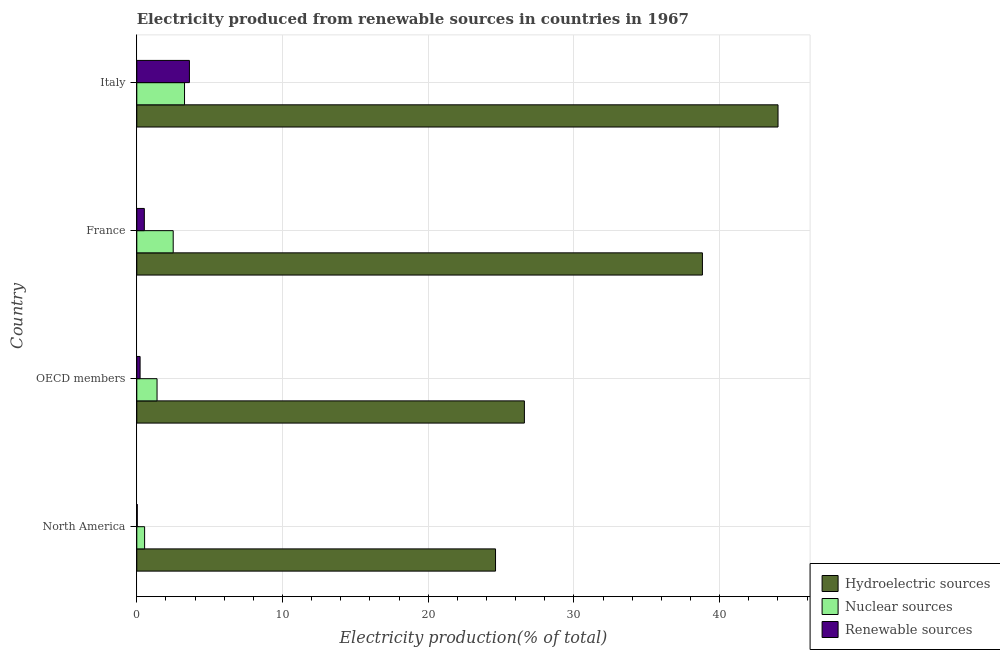How many different coloured bars are there?
Provide a succinct answer. 3. How many groups of bars are there?
Your answer should be compact. 4. In how many cases, is the number of bars for a given country not equal to the number of legend labels?
Provide a short and direct response. 0. What is the percentage of electricity produced by hydroelectric sources in OECD members?
Your answer should be very brief. 26.6. Across all countries, what is the maximum percentage of electricity produced by renewable sources?
Offer a terse response. 3.61. Across all countries, what is the minimum percentage of electricity produced by hydroelectric sources?
Give a very brief answer. 24.62. In which country was the percentage of electricity produced by renewable sources maximum?
Your answer should be compact. Italy. In which country was the percentage of electricity produced by nuclear sources minimum?
Ensure brevity in your answer.  North America. What is the total percentage of electricity produced by hydroelectric sources in the graph?
Provide a succinct answer. 134.03. What is the difference between the percentage of electricity produced by nuclear sources in Italy and that in North America?
Provide a short and direct response. 2.74. What is the difference between the percentage of electricity produced by renewable sources in North America and the percentage of electricity produced by nuclear sources in France?
Give a very brief answer. -2.47. What is the average percentage of electricity produced by nuclear sources per country?
Your answer should be very brief. 1.93. What is the difference between the percentage of electricity produced by renewable sources and percentage of electricity produced by nuclear sources in Italy?
Your answer should be compact. 0.34. What is the ratio of the percentage of electricity produced by renewable sources in Italy to that in North America?
Your answer should be very brief. 110.84. Is the percentage of electricity produced by renewable sources in Italy less than that in OECD members?
Make the answer very short. No. Is the difference between the percentage of electricity produced by hydroelectric sources in North America and OECD members greater than the difference between the percentage of electricity produced by nuclear sources in North America and OECD members?
Keep it short and to the point. No. What is the difference between the highest and the second highest percentage of electricity produced by hydroelectric sources?
Keep it short and to the point. 5.19. What is the difference between the highest and the lowest percentage of electricity produced by hydroelectric sources?
Provide a short and direct response. 19.39. What does the 2nd bar from the top in OECD members represents?
Give a very brief answer. Nuclear sources. What does the 3rd bar from the bottom in France represents?
Make the answer very short. Renewable sources. How many bars are there?
Give a very brief answer. 12. Are all the bars in the graph horizontal?
Keep it short and to the point. Yes. Are the values on the major ticks of X-axis written in scientific E-notation?
Provide a short and direct response. No. Does the graph contain any zero values?
Provide a succinct answer. No. What is the title of the graph?
Your answer should be compact. Electricity produced from renewable sources in countries in 1967. What is the label or title of the Y-axis?
Ensure brevity in your answer.  Country. What is the Electricity production(% of total) in Hydroelectric sources in North America?
Your answer should be very brief. 24.62. What is the Electricity production(% of total) of Nuclear sources in North America?
Offer a very short reply. 0.54. What is the Electricity production(% of total) of Renewable sources in North America?
Give a very brief answer. 0.03. What is the Electricity production(% of total) in Hydroelectric sources in OECD members?
Make the answer very short. 26.6. What is the Electricity production(% of total) of Nuclear sources in OECD members?
Ensure brevity in your answer.  1.39. What is the Electricity production(% of total) in Renewable sources in OECD members?
Offer a very short reply. 0.23. What is the Electricity production(% of total) of Hydroelectric sources in France?
Your response must be concise. 38.81. What is the Electricity production(% of total) in Nuclear sources in France?
Keep it short and to the point. 2.5. What is the Electricity production(% of total) of Renewable sources in France?
Your response must be concise. 0.52. What is the Electricity production(% of total) in Hydroelectric sources in Italy?
Your answer should be very brief. 44. What is the Electricity production(% of total) of Nuclear sources in Italy?
Give a very brief answer. 3.28. What is the Electricity production(% of total) of Renewable sources in Italy?
Your response must be concise. 3.61. Across all countries, what is the maximum Electricity production(% of total) in Hydroelectric sources?
Your response must be concise. 44. Across all countries, what is the maximum Electricity production(% of total) in Nuclear sources?
Provide a short and direct response. 3.28. Across all countries, what is the maximum Electricity production(% of total) of Renewable sources?
Ensure brevity in your answer.  3.61. Across all countries, what is the minimum Electricity production(% of total) of Hydroelectric sources?
Ensure brevity in your answer.  24.62. Across all countries, what is the minimum Electricity production(% of total) of Nuclear sources?
Keep it short and to the point. 0.54. Across all countries, what is the minimum Electricity production(% of total) of Renewable sources?
Your response must be concise. 0.03. What is the total Electricity production(% of total) of Hydroelectric sources in the graph?
Provide a short and direct response. 134.03. What is the total Electricity production(% of total) of Nuclear sources in the graph?
Offer a terse response. 7.7. What is the total Electricity production(% of total) of Renewable sources in the graph?
Provide a succinct answer. 4.39. What is the difference between the Electricity production(% of total) in Hydroelectric sources in North America and that in OECD members?
Your answer should be compact. -1.98. What is the difference between the Electricity production(% of total) in Nuclear sources in North America and that in OECD members?
Offer a very short reply. -0.85. What is the difference between the Electricity production(% of total) in Renewable sources in North America and that in OECD members?
Your answer should be compact. -0.19. What is the difference between the Electricity production(% of total) of Hydroelectric sources in North America and that in France?
Offer a terse response. -14.2. What is the difference between the Electricity production(% of total) of Nuclear sources in North America and that in France?
Provide a short and direct response. -1.96. What is the difference between the Electricity production(% of total) of Renewable sources in North America and that in France?
Ensure brevity in your answer.  -0.48. What is the difference between the Electricity production(% of total) of Hydroelectric sources in North America and that in Italy?
Your response must be concise. -19.39. What is the difference between the Electricity production(% of total) in Nuclear sources in North America and that in Italy?
Make the answer very short. -2.74. What is the difference between the Electricity production(% of total) of Renewable sources in North America and that in Italy?
Keep it short and to the point. -3.58. What is the difference between the Electricity production(% of total) in Hydroelectric sources in OECD members and that in France?
Your answer should be very brief. -12.22. What is the difference between the Electricity production(% of total) of Nuclear sources in OECD members and that in France?
Make the answer very short. -1.11. What is the difference between the Electricity production(% of total) in Renewable sources in OECD members and that in France?
Provide a short and direct response. -0.29. What is the difference between the Electricity production(% of total) in Hydroelectric sources in OECD members and that in Italy?
Ensure brevity in your answer.  -17.4. What is the difference between the Electricity production(% of total) in Nuclear sources in OECD members and that in Italy?
Keep it short and to the point. -1.89. What is the difference between the Electricity production(% of total) of Renewable sources in OECD members and that in Italy?
Make the answer very short. -3.38. What is the difference between the Electricity production(% of total) of Hydroelectric sources in France and that in Italy?
Keep it short and to the point. -5.19. What is the difference between the Electricity production(% of total) in Nuclear sources in France and that in Italy?
Your response must be concise. -0.78. What is the difference between the Electricity production(% of total) in Renewable sources in France and that in Italy?
Keep it short and to the point. -3.09. What is the difference between the Electricity production(% of total) of Hydroelectric sources in North America and the Electricity production(% of total) of Nuclear sources in OECD members?
Give a very brief answer. 23.23. What is the difference between the Electricity production(% of total) of Hydroelectric sources in North America and the Electricity production(% of total) of Renewable sources in OECD members?
Make the answer very short. 24.39. What is the difference between the Electricity production(% of total) in Nuclear sources in North America and the Electricity production(% of total) in Renewable sources in OECD members?
Your answer should be compact. 0.31. What is the difference between the Electricity production(% of total) of Hydroelectric sources in North America and the Electricity production(% of total) of Nuclear sources in France?
Your answer should be very brief. 22.12. What is the difference between the Electricity production(% of total) in Hydroelectric sources in North America and the Electricity production(% of total) in Renewable sources in France?
Offer a terse response. 24.1. What is the difference between the Electricity production(% of total) of Nuclear sources in North America and the Electricity production(% of total) of Renewable sources in France?
Your answer should be compact. 0.02. What is the difference between the Electricity production(% of total) in Hydroelectric sources in North America and the Electricity production(% of total) in Nuclear sources in Italy?
Provide a short and direct response. 21.34. What is the difference between the Electricity production(% of total) in Hydroelectric sources in North America and the Electricity production(% of total) in Renewable sources in Italy?
Keep it short and to the point. 21.01. What is the difference between the Electricity production(% of total) of Nuclear sources in North America and the Electricity production(% of total) of Renewable sources in Italy?
Your answer should be compact. -3.08. What is the difference between the Electricity production(% of total) of Hydroelectric sources in OECD members and the Electricity production(% of total) of Nuclear sources in France?
Ensure brevity in your answer.  24.1. What is the difference between the Electricity production(% of total) of Hydroelectric sources in OECD members and the Electricity production(% of total) of Renewable sources in France?
Ensure brevity in your answer.  26.08. What is the difference between the Electricity production(% of total) of Nuclear sources in OECD members and the Electricity production(% of total) of Renewable sources in France?
Keep it short and to the point. 0.87. What is the difference between the Electricity production(% of total) of Hydroelectric sources in OECD members and the Electricity production(% of total) of Nuclear sources in Italy?
Your answer should be compact. 23.32. What is the difference between the Electricity production(% of total) in Hydroelectric sources in OECD members and the Electricity production(% of total) in Renewable sources in Italy?
Your answer should be compact. 22.99. What is the difference between the Electricity production(% of total) of Nuclear sources in OECD members and the Electricity production(% of total) of Renewable sources in Italy?
Your answer should be compact. -2.22. What is the difference between the Electricity production(% of total) of Hydroelectric sources in France and the Electricity production(% of total) of Nuclear sources in Italy?
Ensure brevity in your answer.  35.54. What is the difference between the Electricity production(% of total) in Hydroelectric sources in France and the Electricity production(% of total) in Renewable sources in Italy?
Provide a succinct answer. 35.2. What is the difference between the Electricity production(% of total) of Nuclear sources in France and the Electricity production(% of total) of Renewable sources in Italy?
Your response must be concise. -1.11. What is the average Electricity production(% of total) in Hydroelectric sources per country?
Make the answer very short. 33.51. What is the average Electricity production(% of total) of Nuclear sources per country?
Your response must be concise. 1.93. What is the average Electricity production(% of total) in Renewable sources per country?
Give a very brief answer. 1.1. What is the difference between the Electricity production(% of total) of Hydroelectric sources and Electricity production(% of total) of Nuclear sources in North America?
Your answer should be very brief. 24.08. What is the difference between the Electricity production(% of total) in Hydroelectric sources and Electricity production(% of total) in Renewable sources in North America?
Your response must be concise. 24.59. What is the difference between the Electricity production(% of total) in Nuclear sources and Electricity production(% of total) in Renewable sources in North America?
Provide a succinct answer. 0.5. What is the difference between the Electricity production(% of total) in Hydroelectric sources and Electricity production(% of total) in Nuclear sources in OECD members?
Keep it short and to the point. 25.21. What is the difference between the Electricity production(% of total) in Hydroelectric sources and Electricity production(% of total) in Renewable sources in OECD members?
Give a very brief answer. 26.37. What is the difference between the Electricity production(% of total) in Nuclear sources and Electricity production(% of total) in Renewable sources in OECD members?
Give a very brief answer. 1.16. What is the difference between the Electricity production(% of total) of Hydroelectric sources and Electricity production(% of total) of Nuclear sources in France?
Offer a very short reply. 36.32. What is the difference between the Electricity production(% of total) in Hydroelectric sources and Electricity production(% of total) in Renewable sources in France?
Make the answer very short. 38.3. What is the difference between the Electricity production(% of total) of Nuclear sources and Electricity production(% of total) of Renewable sources in France?
Keep it short and to the point. 1.98. What is the difference between the Electricity production(% of total) of Hydroelectric sources and Electricity production(% of total) of Nuclear sources in Italy?
Your answer should be compact. 40.73. What is the difference between the Electricity production(% of total) in Hydroelectric sources and Electricity production(% of total) in Renewable sources in Italy?
Provide a succinct answer. 40.39. What is the difference between the Electricity production(% of total) of Nuclear sources and Electricity production(% of total) of Renewable sources in Italy?
Your answer should be compact. -0.34. What is the ratio of the Electricity production(% of total) of Hydroelectric sources in North America to that in OECD members?
Your answer should be compact. 0.93. What is the ratio of the Electricity production(% of total) of Nuclear sources in North America to that in OECD members?
Ensure brevity in your answer.  0.39. What is the ratio of the Electricity production(% of total) in Renewable sources in North America to that in OECD members?
Keep it short and to the point. 0.14. What is the ratio of the Electricity production(% of total) in Hydroelectric sources in North America to that in France?
Provide a succinct answer. 0.63. What is the ratio of the Electricity production(% of total) in Nuclear sources in North America to that in France?
Your response must be concise. 0.21. What is the ratio of the Electricity production(% of total) of Renewable sources in North America to that in France?
Provide a short and direct response. 0.06. What is the ratio of the Electricity production(% of total) in Hydroelectric sources in North America to that in Italy?
Keep it short and to the point. 0.56. What is the ratio of the Electricity production(% of total) of Nuclear sources in North America to that in Italy?
Provide a short and direct response. 0.16. What is the ratio of the Electricity production(% of total) in Renewable sources in North America to that in Italy?
Your response must be concise. 0.01. What is the ratio of the Electricity production(% of total) in Hydroelectric sources in OECD members to that in France?
Provide a succinct answer. 0.69. What is the ratio of the Electricity production(% of total) of Nuclear sources in OECD members to that in France?
Provide a short and direct response. 0.56. What is the ratio of the Electricity production(% of total) in Renewable sources in OECD members to that in France?
Give a very brief answer. 0.44. What is the ratio of the Electricity production(% of total) of Hydroelectric sources in OECD members to that in Italy?
Provide a succinct answer. 0.6. What is the ratio of the Electricity production(% of total) of Nuclear sources in OECD members to that in Italy?
Ensure brevity in your answer.  0.42. What is the ratio of the Electricity production(% of total) in Renewable sources in OECD members to that in Italy?
Offer a terse response. 0.06. What is the ratio of the Electricity production(% of total) of Hydroelectric sources in France to that in Italy?
Offer a very short reply. 0.88. What is the ratio of the Electricity production(% of total) of Nuclear sources in France to that in Italy?
Your response must be concise. 0.76. What is the ratio of the Electricity production(% of total) in Renewable sources in France to that in Italy?
Provide a short and direct response. 0.14. What is the difference between the highest and the second highest Electricity production(% of total) of Hydroelectric sources?
Ensure brevity in your answer.  5.19. What is the difference between the highest and the second highest Electricity production(% of total) of Nuclear sources?
Ensure brevity in your answer.  0.78. What is the difference between the highest and the second highest Electricity production(% of total) of Renewable sources?
Give a very brief answer. 3.09. What is the difference between the highest and the lowest Electricity production(% of total) of Hydroelectric sources?
Give a very brief answer. 19.39. What is the difference between the highest and the lowest Electricity production(% of total) in Nuclear sources?
Your answer should be very brief. 2.74. What is the difference between the highest and the lowest Electricity production(% of total) in Renewable sources?
Your answer should be compact. 3.58. 